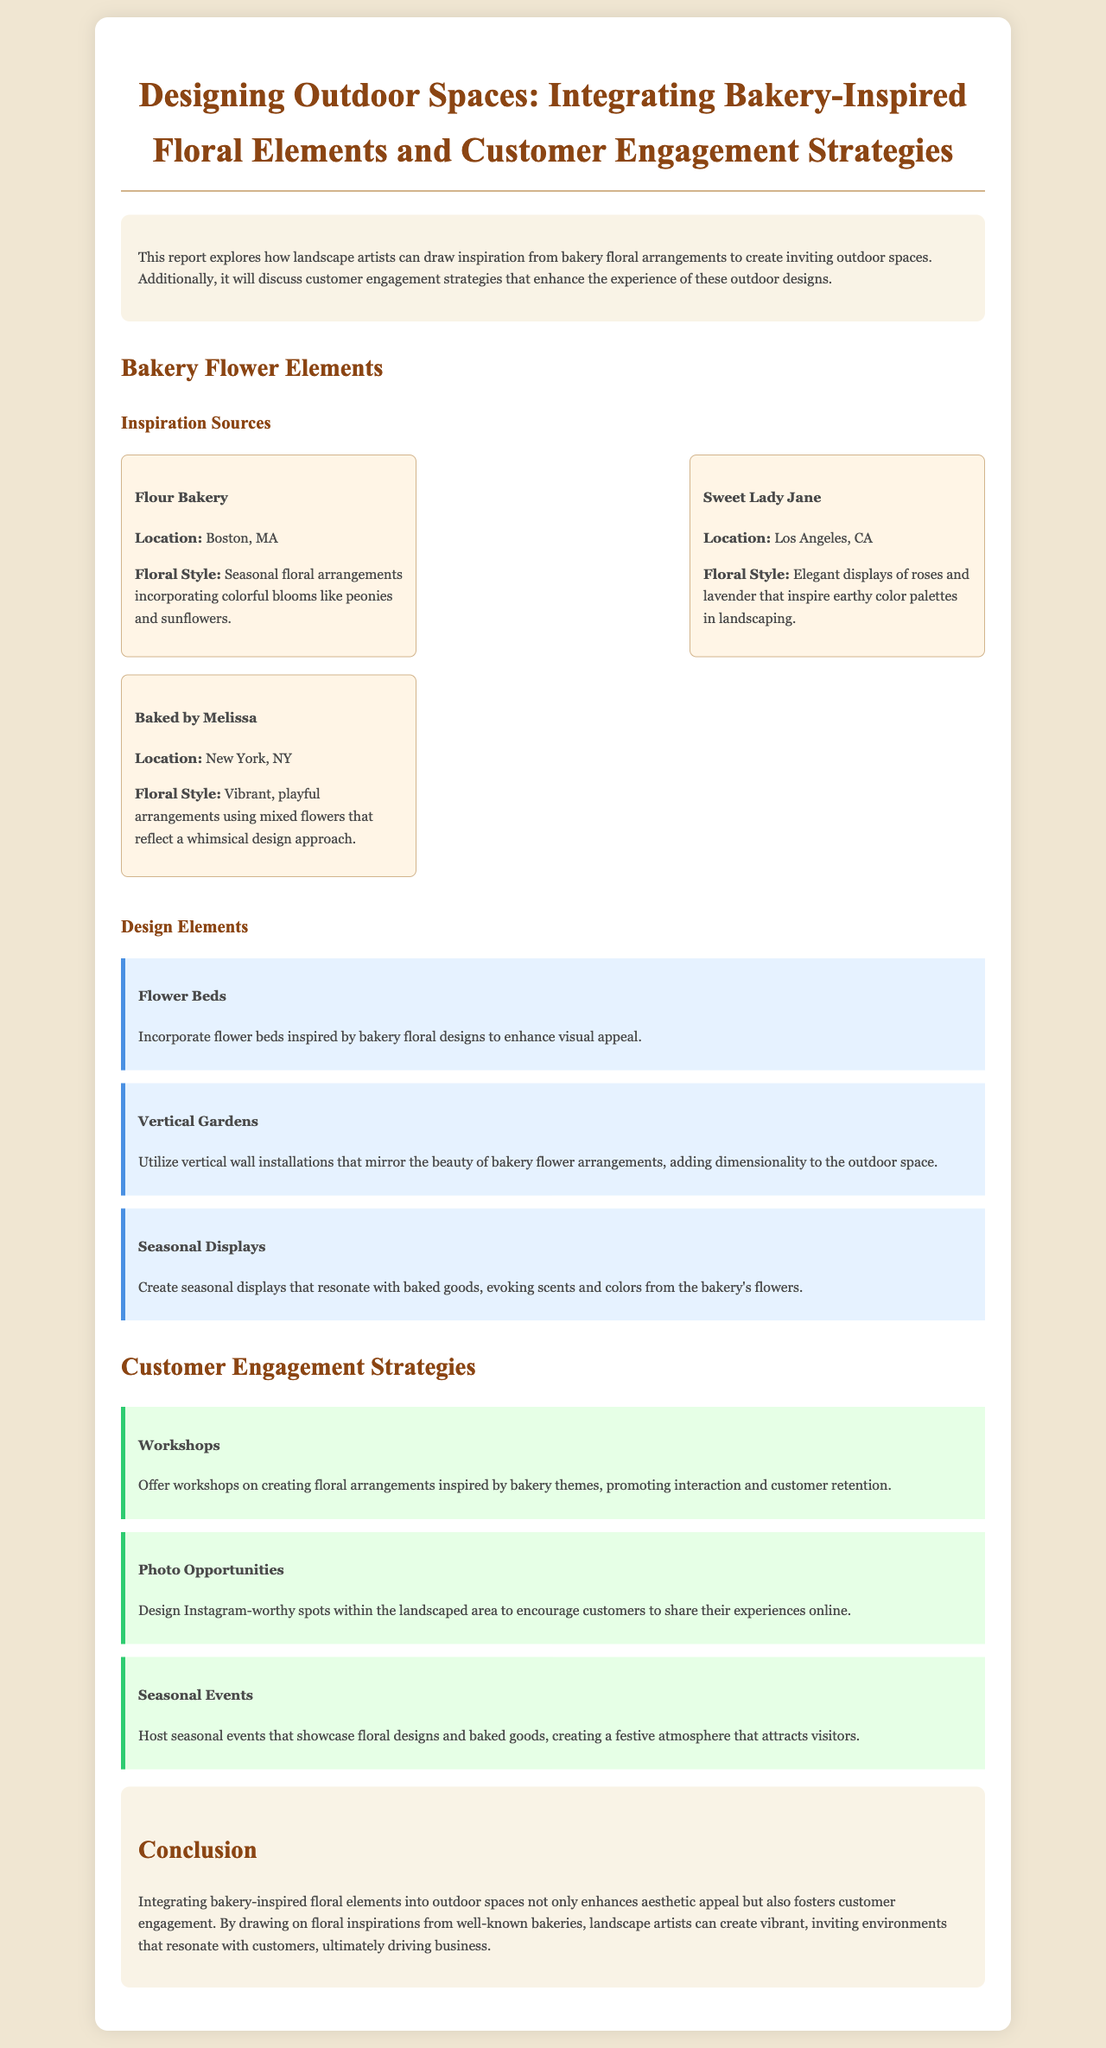What is the title of the report? The title of the report is stated in the header of the document.
Answer: Designing Outdoor Spaces: Integrating Bakery-Inspired Floral Elements and Customer Engagement Strategies Where is Flour Bakery located? The location of Flour Bakery is specified in the bakery inspiration section.
Answer: Boston, MA What floral style is associated with Sweet Lady Jane? The floral style of Sweet Lady Jane is mentioned in the description of the bakery.
Answer: Elegant displays of roses and lavender What design element suggests using vertical wall installations? The specific design element that is suggested for vertical wall installations is identified in the design elements section.
Answer: Vertical Gardens What customer engagement strategy involves interaction through workshops? The customer engagement strategy that promotes interaction through workshops is listed in the strategies section.
Answer: Workshops How many bakeries are mentioned in the inspiration sources? The number of bakeries within the bakery inspiration section is counted for a total.
Answer: Three What type of display is suggested to resonate with baked goods? The type of display that evokes the scents and colors of baked goods is detailed in the design elements section.
Answer: Seasonal Displays What is one purpose of creating photo opportunities? The purpose of designing Instagram-worthy spots is explained in the customer engagement strategies.
Answer: Encourage customers to share their experiences What overall benefit does integrating bakery-inspired floral elements offer? The benefit of integrating these floral elements is summarized in the conclusion of the report.
Answer: Enhances aesthetic appeal 